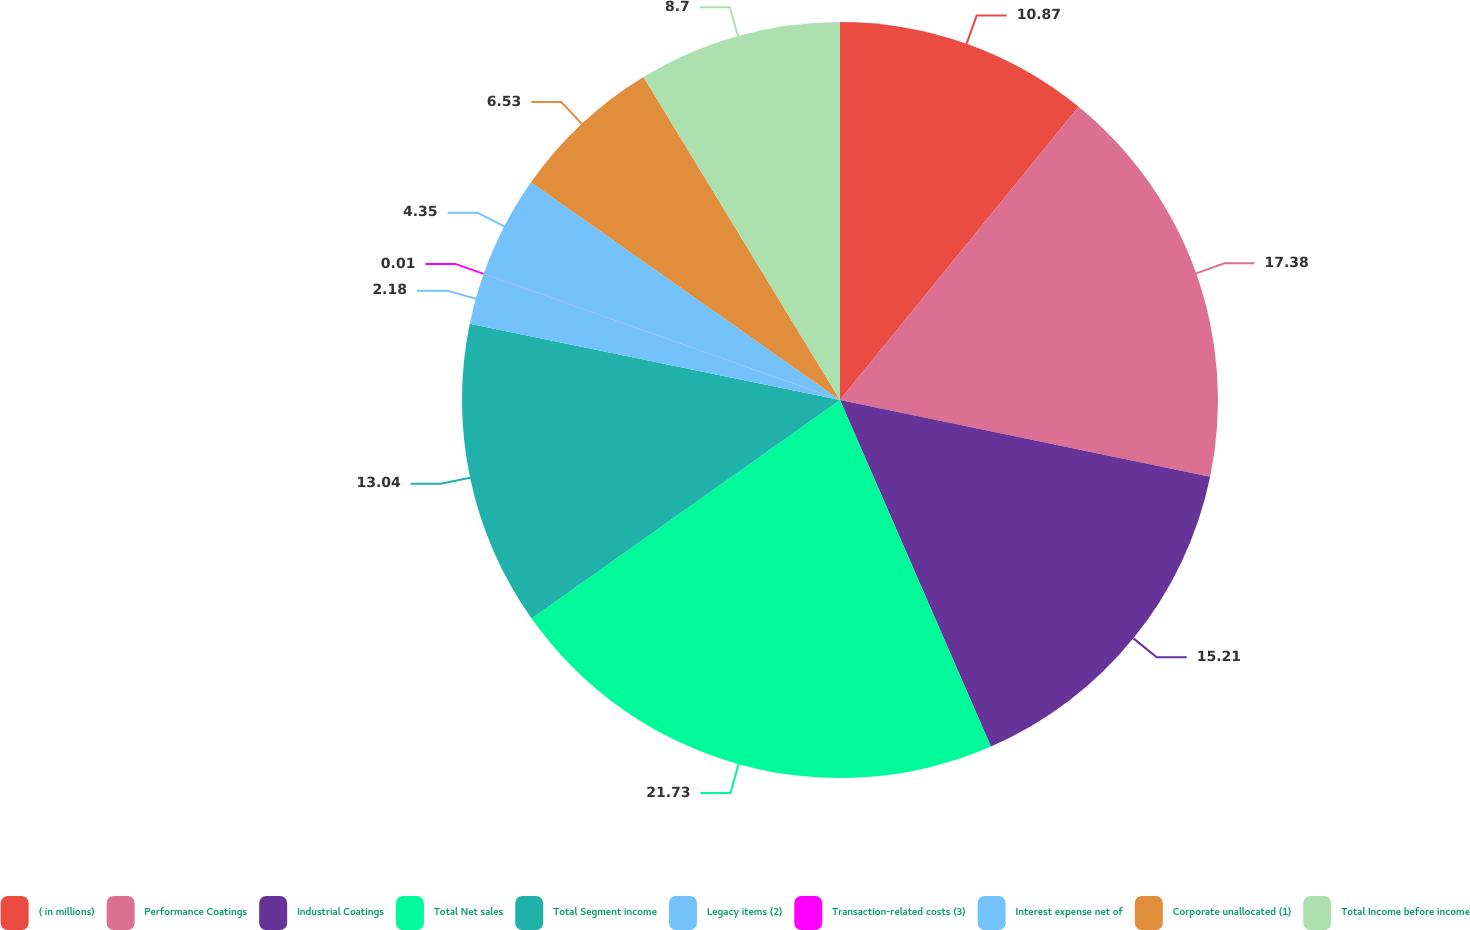Convert chart. <chart><loc_0><loc_0><loc_500><loc_500><pie_chart><fcel>( in millions)<fcel>Performance Coatings<fcel>Industrial Coatings<fcel>Total Net sales<fcel>Total Segment income<fcel>Legacy items (2)<fcel>Transaction-related costs (3)<fcel>Interest expense net of<fcel>Corporate unallocated (1)<fcel>Total Income before income<nl><fcel>10.87%<fcel>17.38%<fcel>15.21%<fcel>21.72%<fcel>13.04%<fcel>2.18%<fcel>0.01%<fcel>4.35%<fcel>6.53%<fcel>8.7%<nl></chart> 